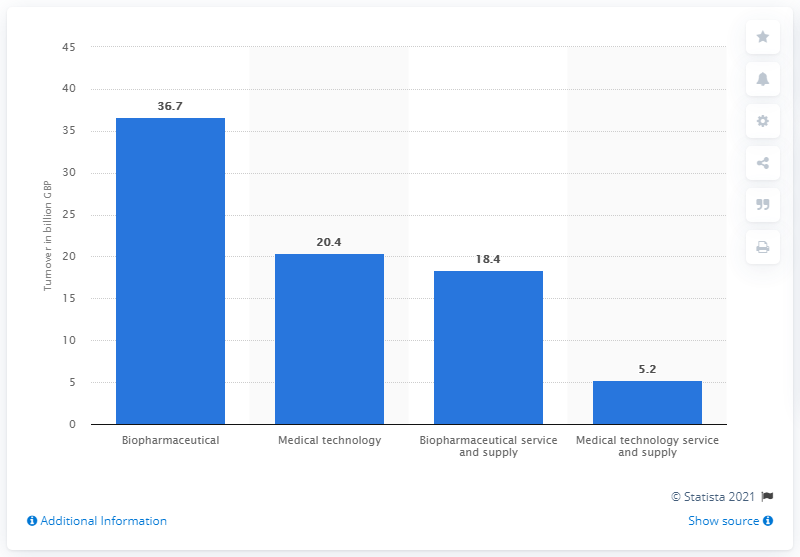Outline some significant characteristics in this image. In 2019, the medical technology sector had a turnover of 20.4 billion U.S. dollars. The turnover of the biopharmaceutical sector in 2019 was $36.7 billion. 